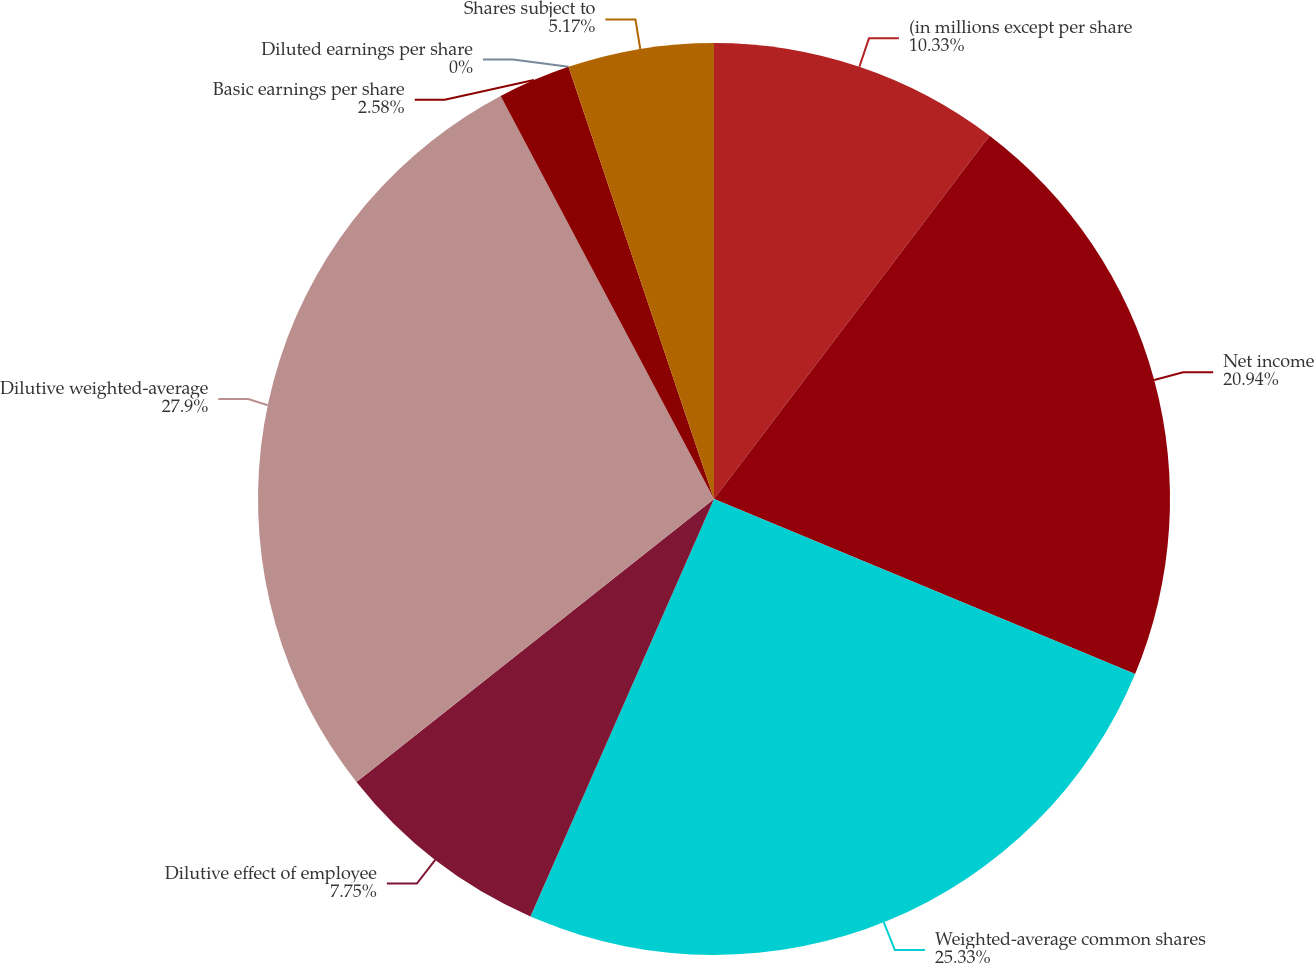Convert chart to OTSL. <chart><loc_0><loc_0><loc_500><loc_500><pie_chart><fcel>(in millions except per share<fcel>Net income<fcel>Weighted-average common shares<fcel>Dilutive effect of employee<fcel>Dilutive weighted-average<fcel>Basic earnings per share<fcel>Diluted earnings per share<fcel>Shares subject to<nl><fcel>10.33%<fcel>20.94%<fcel>25.33%<fcel>7.75%<fcel>27.91%<fcel>2.58%<fcel>0.0%<fcel>5.17%<nl></chart> 